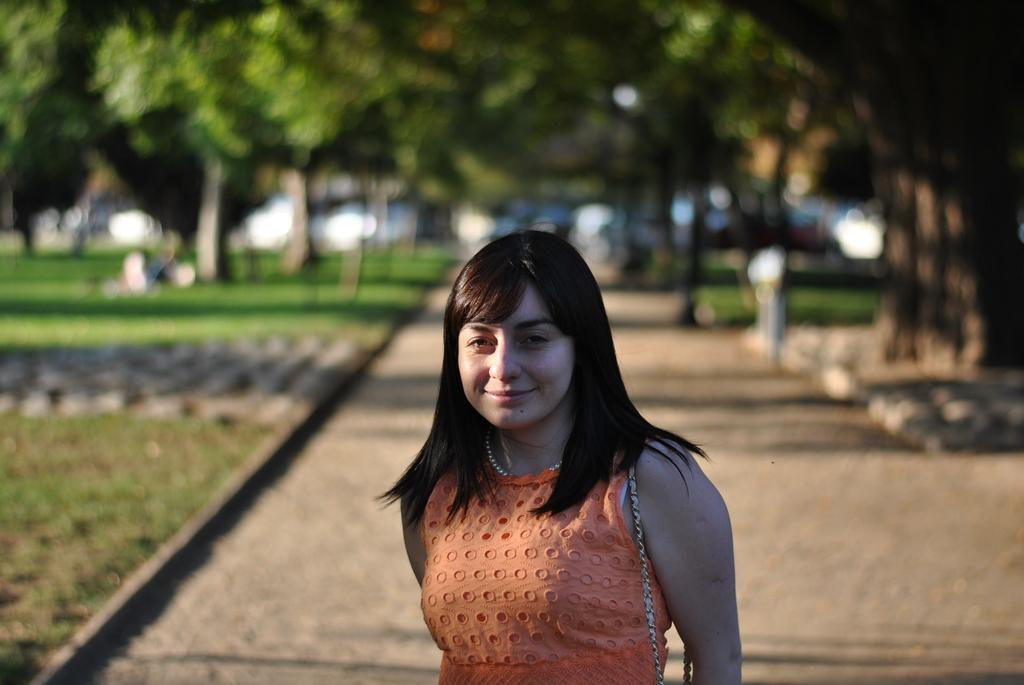Who is the main subject in the image? There is a girl in the image. What is the girl wearing? The girl is wearing a brown dress. What is the girl doing in the image? The girl is standing and smiling. What can be seen in the background of the image? There are many trees in the background of the image. What type of vegetation is on the left side of the image? There is a grass lawn on the left side of the image. What type of ring can be seen on the girl's finger in the image? There is no ring visible on the girl's finger in the image. Does the girl express any feelings of hate in the image? The girl is smiling in the image, which suggests a positive emotion rather than hate. 